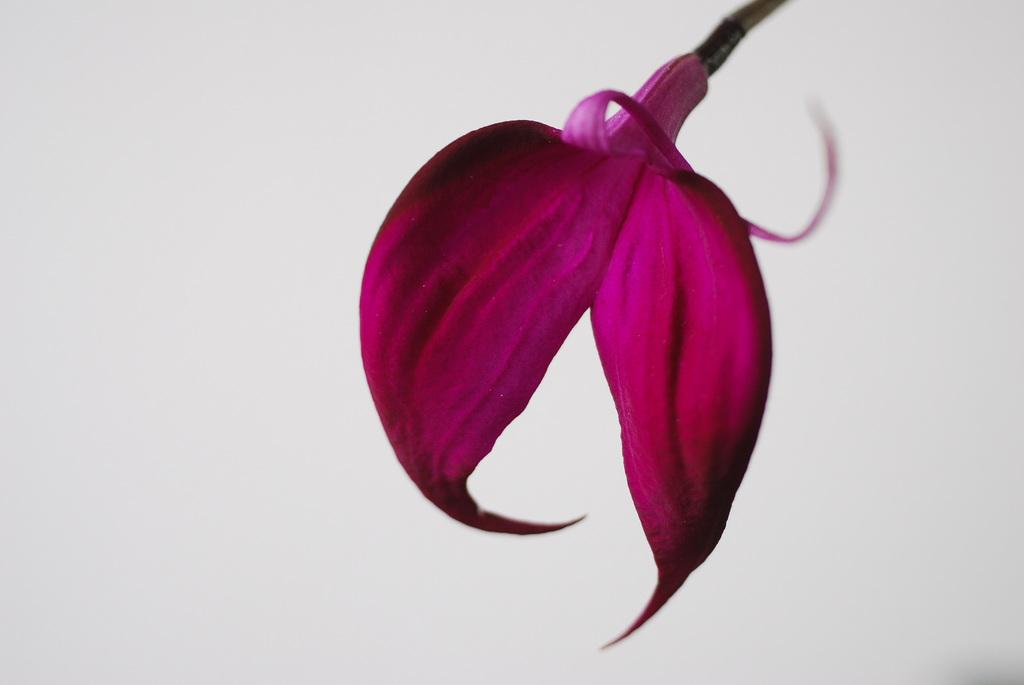What is the main subject of the picture? The main subject of the picture is a flower. What color is the flower? The flower is in violet color. What color is the background of the image? The background of the image is white. What type of pest can be seen crawling on the flower in the image? There is no pest visible on the flower in the image. What brand of toothpaste is advertised on the flower in the image? There is no toothpaste or advertisement present in the image; it features a violet flower against a white background. 